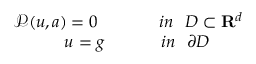<formula> <loc_0><loc_0><loc_500><loc_500>\begin{array} { r } { \mathcal { P } ( u , a ) = 0 i n D \subset R ^ { d } } \\ { u = g i n \partial D } \end{array}</formula> 